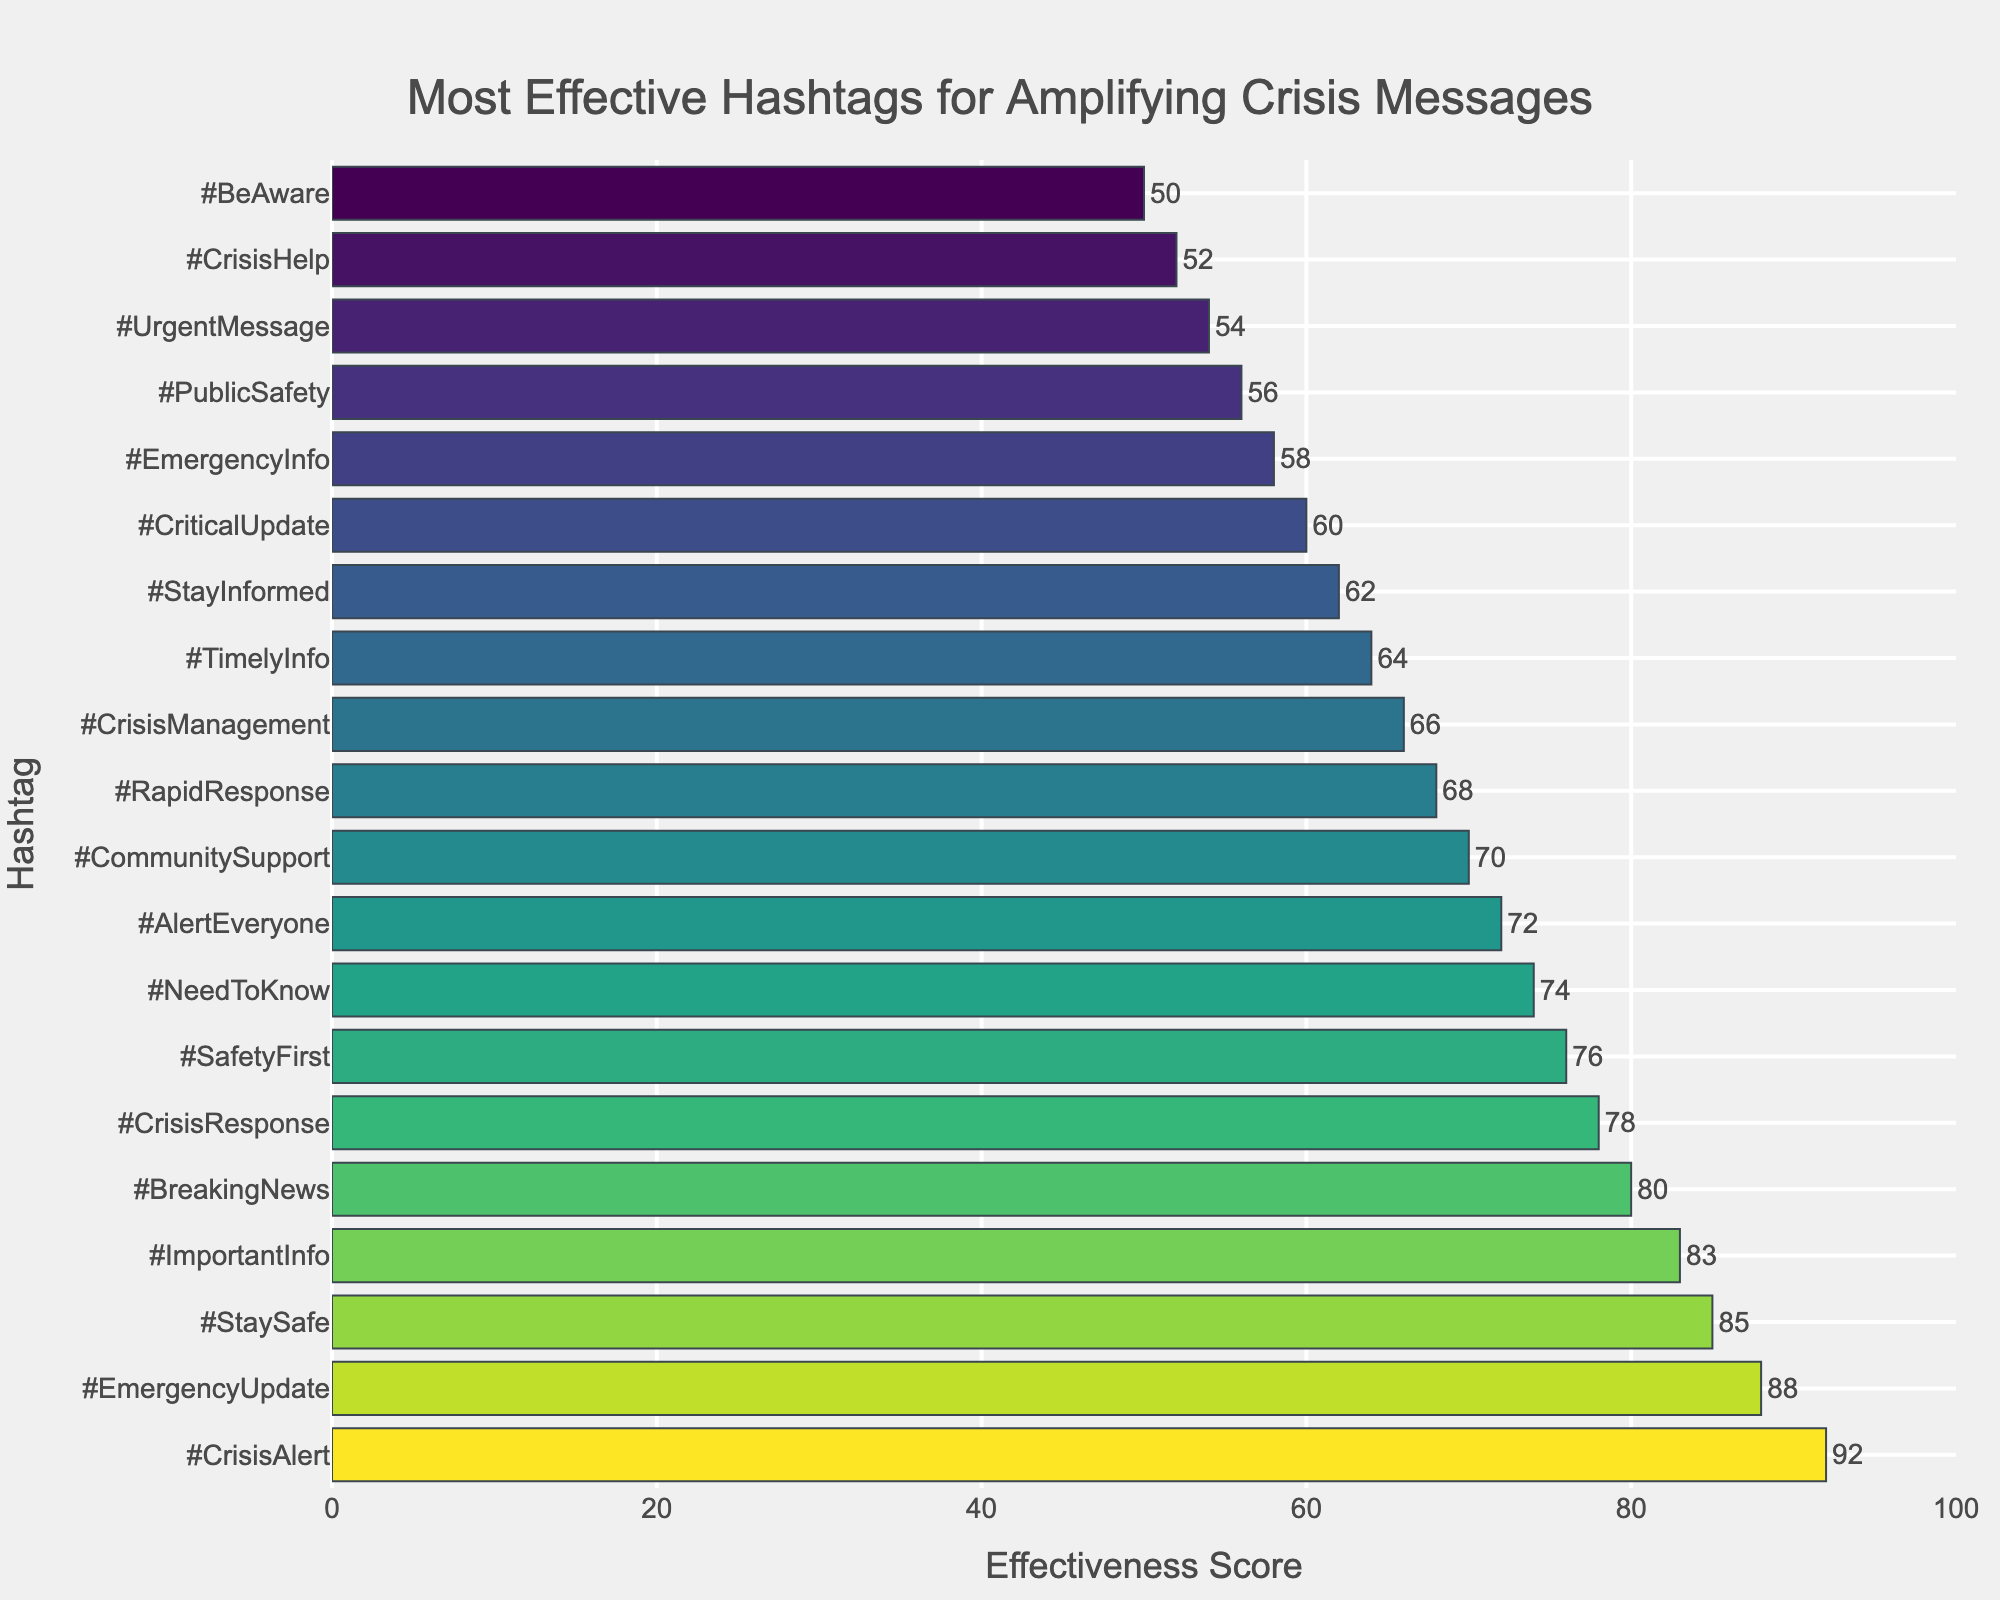What is the most effective hashtag for amplifying crisis messages? The most effective hashtag will have the highest effectiveness score and appear at the top of the sorted bar chart. The hashtag #CrisisAlert, with an effectiveness score of 92, is at the top of the chart.
Answer: #CrisisAlert Which hashtag has the least effectiveness in amplifying crisis messages? The least effective hashtag will have the lowest effectiveness score and will appear at the bottom of the sorted bar chart. The hashtag #BeAware, with an effectiveness score of 50, is at the bottom of the chart.
Answer: #BeAware What is the effectiveness score difference between #CrisisAlert and #BeAware? The effectiveness score of #CrisisAlert is 92, and the effectiveness score of #BeAware is 50. The difference is calculated as 92 - 50.
Answer: 42 What hashtags have an effectiveness score above 80? Hashtags with an effectiveness score above 80 will have scores greater than 80 on the chart. The hashtags #CrisisAlert (92), #EmergencyUpdate (88), #StaySafe (85), and #ImportantInfo (83) have scores above 80.
Answer: #CrisisAlert, #EmergencyUpdate, #StaySafe, #ImportantInfo How does the effectiveness score of #CrisisResponse compare to #ImportantInfo? To compare, locate the bars for both hashtags and compare their lengths/effectiveness scores. #CrisisResponse has an effectiveness score of 78, and #ImportantInfo has a score of 83. Since 78 is less than 83, #CrisisResponse is less effective than #ImportantInfo.
Answer: #CrisisResponse is less effective than #ImportantInfo What are the total effectiveness scores of the top 3 hashtags combined? Sum the effectiveness scores of #CrisisAlert (92), #EmergencyUpdate (88), and #StaySafe (85). Adding them together gives 92 + 88 + 85.
Answer: 265 How many hashtags have an effectiveness score between 70 and 80? Count the hashtags whose effectiveness scores fall within the range 70 to 80. The hashtags are #BreakingNews (80), #CrisisResponse (78), #SafetyFirst (76), #NeedToKnow (74), and #AlertEveryone (72), totaling 5 hashtags.
Answer: 5 Which hashtag is ranked directly below #StaySafe in effectiveness? Identify the bar directly below #StaySafe on the chart. The hashtag #ImportantInfo is directly below #StaySafe.
Answer: #ImportantInfo Arrange hashtags #CrisisHelp, #TimelyInfo, and #UrgentMessage in descending order of their effectiveness scores. Find the effectiveness scores for these hashtags: #CrisisHelp (52), #TimelyInfo (64), and #UrgentMessage (54), and arrange them from highest to lowest score.
Answer: #TimelyInfo, #UrgentMessage, #CrisisHelp What is the average effectiveness score of the bottom 5 hashtags? Find the effectiveness scores of the bottom 5 hashtags: #BeAware (50), #CrisisHelp (52), #UrgentMessage (54), #PublicSafety (56), and #EmergencyInfo (58). Sum them up (50 + 52 + 54 + 56 + 58) and divide by 5.
Answer: 54 